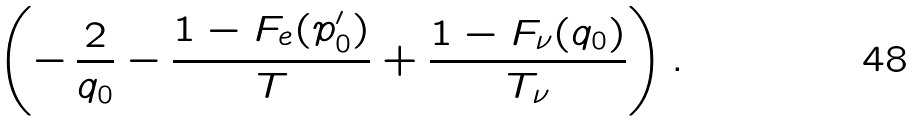Convert formula to latex. <formula><loc_0><loc_0><loc_500><loc_500>\left ( - \, \frac { 2 } { q _ { 0 } } - \frac { 1 - F _ { e } ( p _ { 0 } ^ { \prime } ) } { T } + \frac { 1 - F _ { \nu } ( q _ { 0 } ) } { T _ { \nu } } \right ) .</formula> 